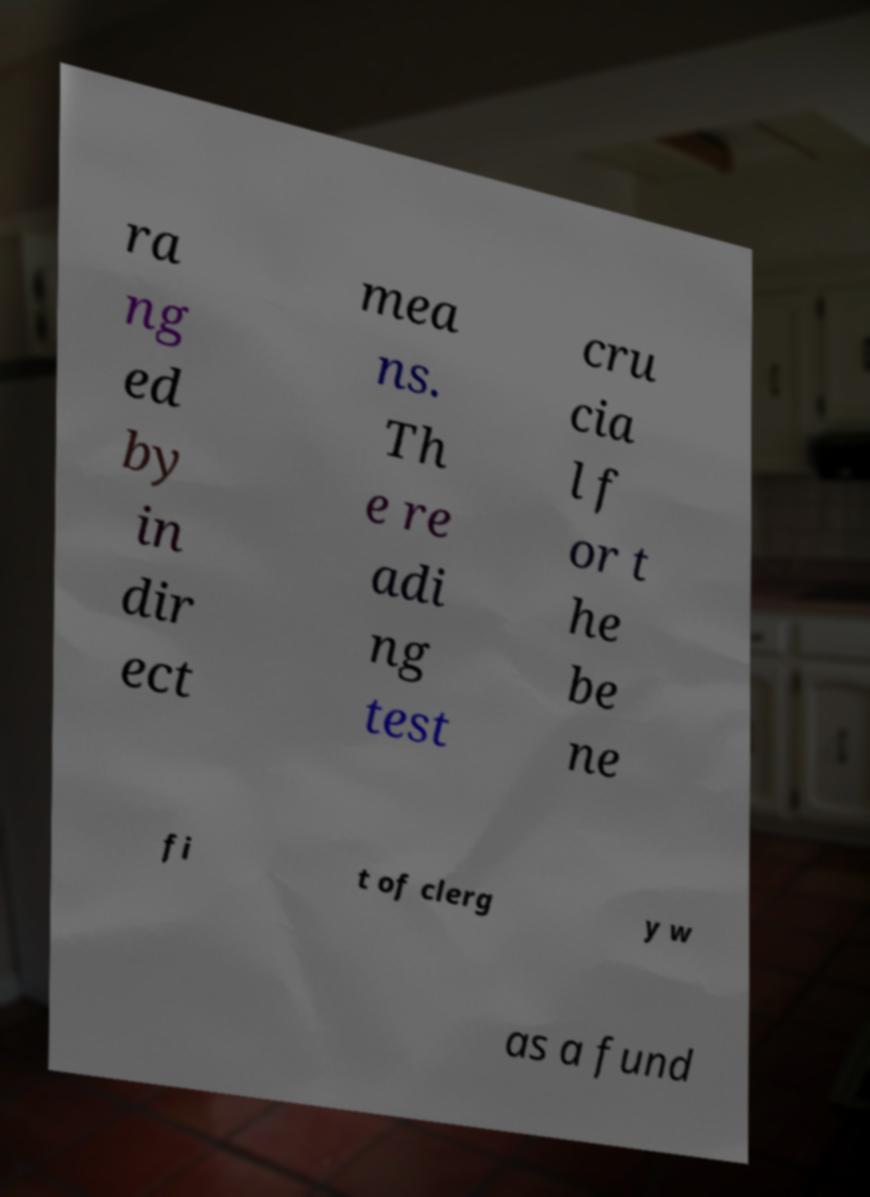Can you read and provide the text displayed in the image?This photo seems to have some interesting text. Can you extract and type it out for me? ra ng ed by in dir ect mea ns. Th e re adi ng test cru cia l f or t he be ne fi t of clerg y w as a fund 